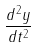<formula> <loc_0><loc_0><loc_500><loc_500>\frac { d ^ { 2 } y } { d t ^ { 2 } }</formula> 